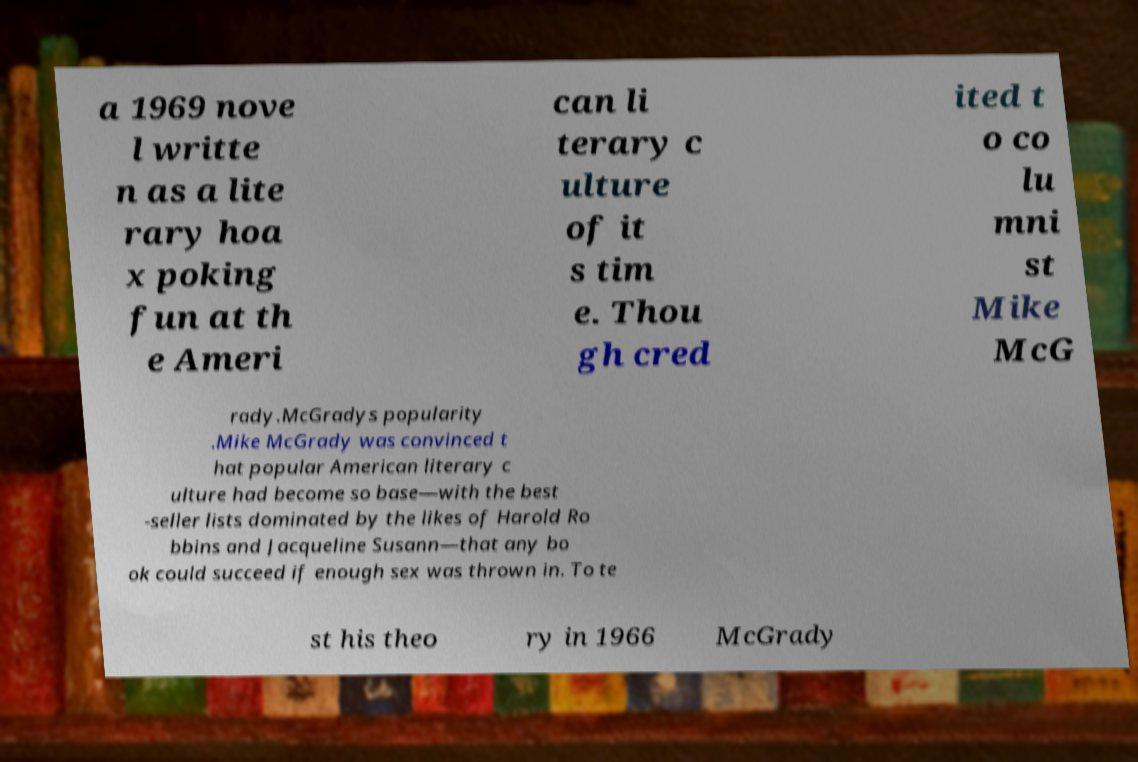Can you read and provide the text displayed in the image?This photo seems to have some interesting text. Can you extract and type it out for me? a 1969 nove l writte n as a lite rary hoa x poking fun at th e Ameri can li terary c ulture of it s tim e. Thou gh cred ited t o co lu mni st Mike McG rady.McGradys popularity .Mike McGrady was convinced t hat popular American literary c ulture had become so base—with the best -seller lists dominated by the likes of Harold Ro bbins and Jacqueline Susann—that any bo ok could succeed if enough sex was thrown in. To te st his theo ry in 1966 McGrady 